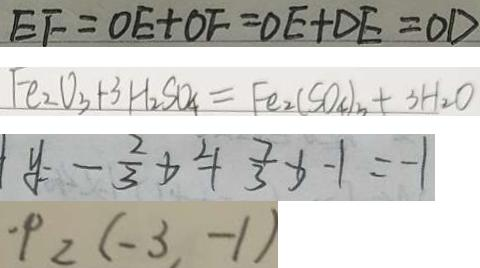Convert formula to latex. <formula><loc_0><loc_0><loc_500><loc_500>E F = O E + O F = O E + D E = O E + O E = O E + D E = O E 
 F e _ { 2 } O _ { 3 } + 3 H _ { 2 } S O _ { 4 } = F e _ { 2 } ( S O _ { 4 } ) _ { n } + 3 H _ { 2 } O 
 y = - \frac { 2 } { 3 } x ^ { 2 } + \frac { 7 } { 3 } x - 1 = - 1 
 \cdot P _ { 2 } ( - 3 , - 1 )</formula> 